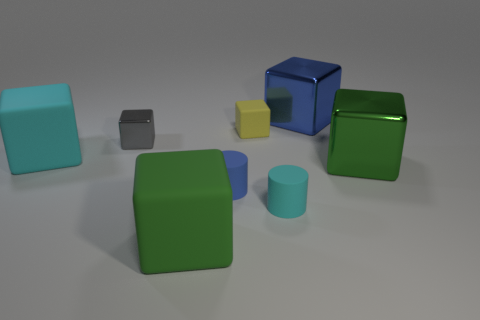What colors are used in these objects, and which one is the smallest? The objects exhibit a variety of colors like blue, green, teal, yellow, and grey. The smallest object is the grey cuboid at the center of the image. Is there any pattern to the arrangement of these objects? While there's no clear pattern, the objects are arranged with a sense of balance, with the colors and sizes distributed such that no single area of the image is overwhelmingly occupied or vacant. 